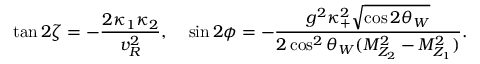Convert formula to latex. <formula><loc_0><loc_0><loc_500><loc_500>\tan { 2 \zeta } = - \frac { 2 \kappa _ { 1 } \kappa _ { 2 } } { v _ { R } ^ { 2 } } , \, \sin { 2 \phi } = - \frac { g ^ { 2 } \kappa _ { + } ^ { 2 } \sqrt { \cos { 2 \theta _ { W } } } } { 2 \cos ^ { 2 } { \theta _ { W } } ( M _ { Z _ { 2 } } ^ { 2 } - M _ { Z _ { 1 } } ^ { 2 } ) } .</formula> 